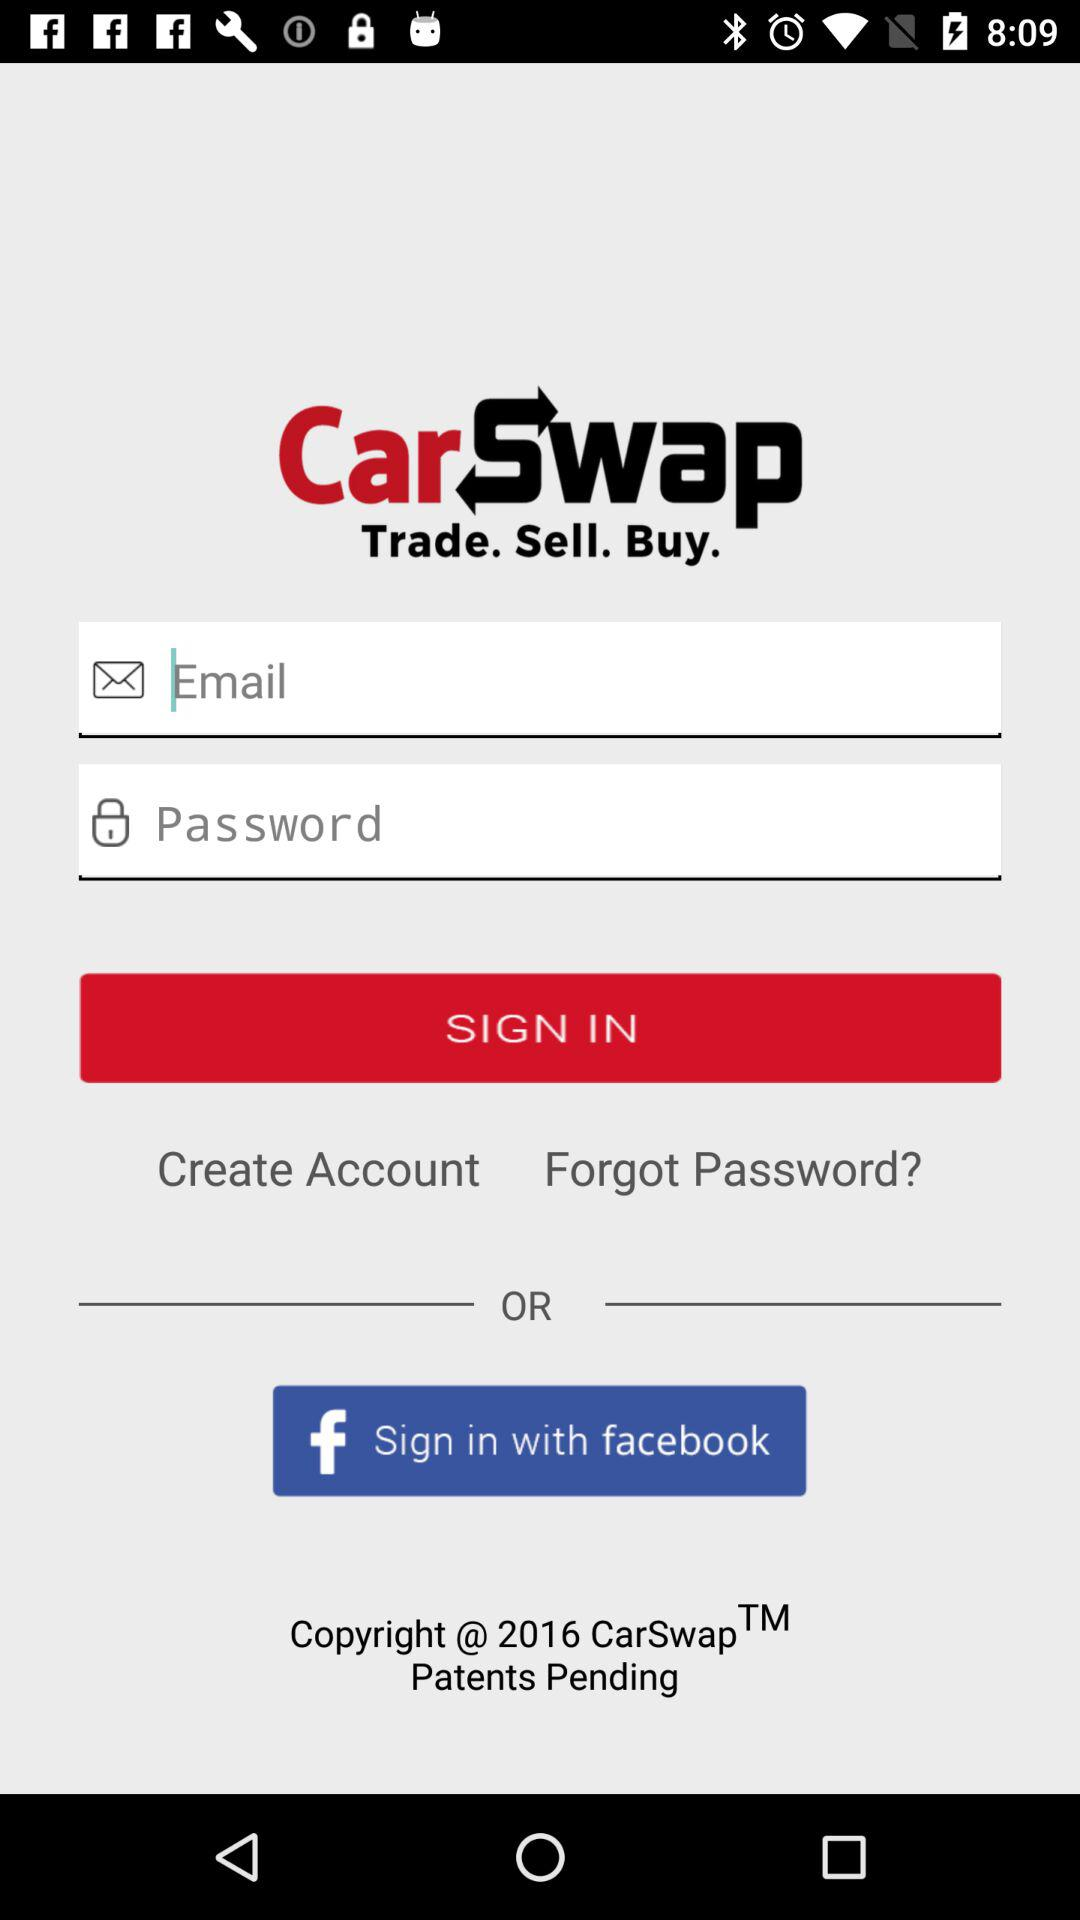In what year did the application get the copyright? The application got the copyright in 2016. 